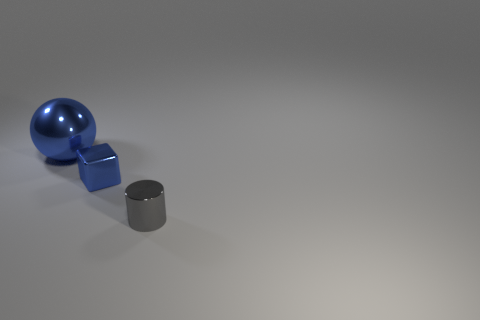Does the blue thing that is in front of the blue ball have the same material as the blue object on the left side of the metal block?
Your response must be concise. Yes. What number of big metallic cylinders are there?
Provide a short and direct response. 0. What number of big shiny objects are the same shape as the tiny gray metallic object?
Offer a very short reply. 0. Is the small gray shiny object the same shape as the small blue thing?
Your response must be concise. No. The metal cylinder is what size?
Provide a succinct answer. Small. How many gray shiny cylinders have the same size as the blue shiny sphere?
Offer a very short reply. 0. There is a blue shiny object in front of the large shiny ball; is it the same size as the thing that is in front of the small block?
Your answer should be very brief. Yes. There is a blue thing that is to the right of the big blue shiny ball; what is its shape?
Make the answer very short. Cube. What is the material of the cylinder that is right of the small thing that is behind the gray metallic object?
Provide a short and direct response. Metal. Is there a small metallic object of the same color as the large ball?
Your answer should be very brief. Yes. 